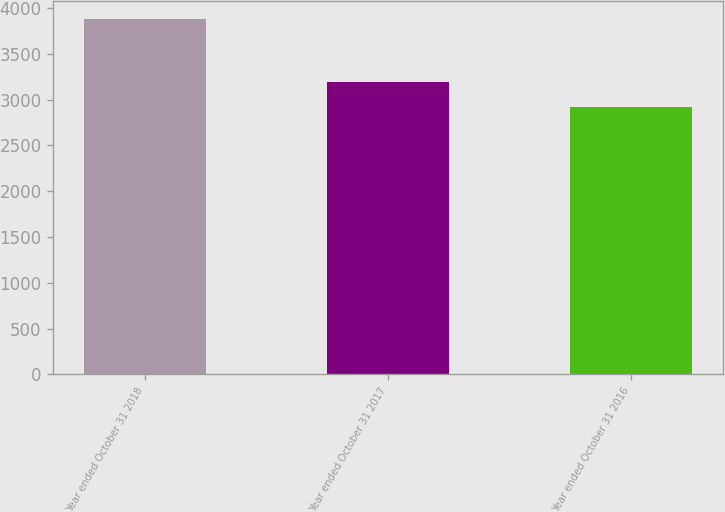<chart> <loc_0><loc_0><loc_500><loc_500><bar_chart><fcel>Year ended October 31 2018<fcel>Year ended October 31 2017<fcel>Year ended October 31 2016<nl><fcel>3878<fcel>3189<fcel>2918<nl></chart> 